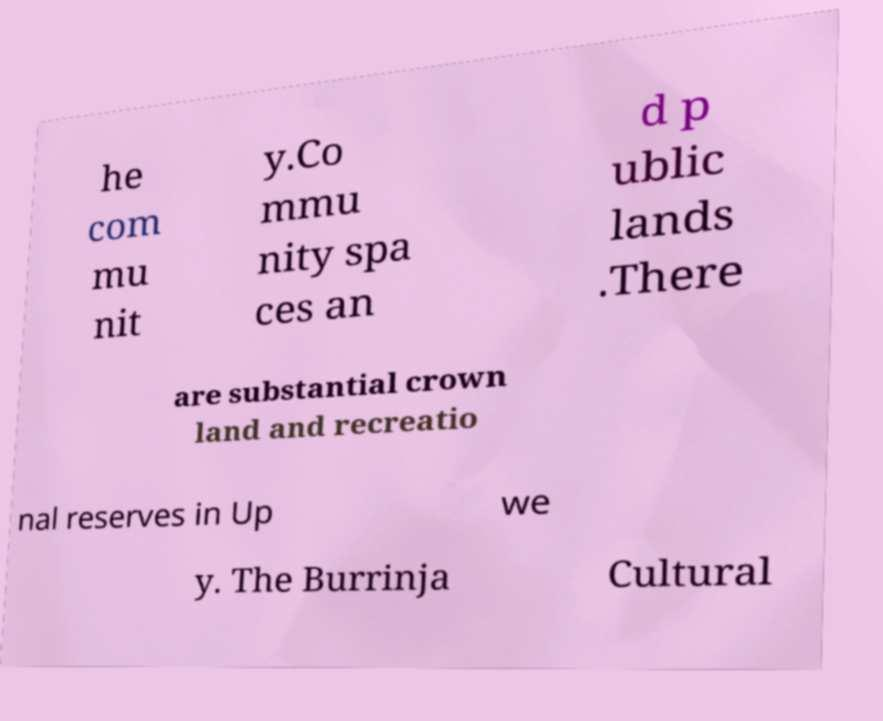There's text embedded in this image that I need extracted. Can you transcribe it verbatim? he com mu nit y.Co mmu nity spa ces an d p ublic lands .There are substantial crown land and recreatio nal reserves in Up we y. The Burrinja Cultural 